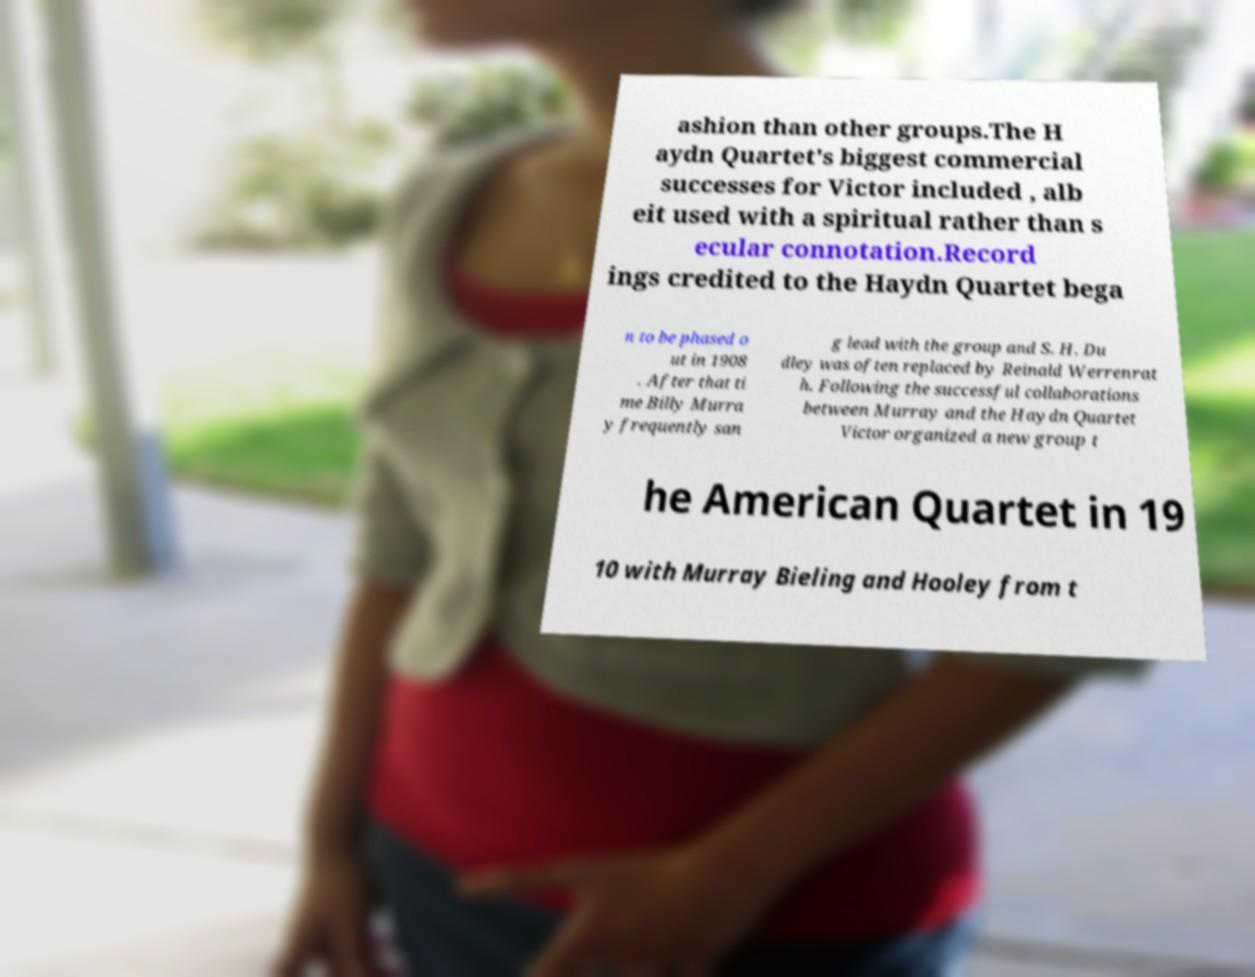Can you accurately transcribe the text from the provided image for me? ashion than other groups.The H aydn Quartet's biggest commercial successes for Victor included , alb eit used with a spiritual rather than s ecular connotation.Record ings credited to the Haydn Quartet bega n to be phased o ut in 1908 . After that ti me Billy Murra y frequently san g lead with the group and S. H. Du dley was often replaced by Reinald Werrenrat h. Following the successful collaborations between Murray and the Haydn Quartet Victor organized a new group t he American Quartet in 19 10 with Murray Bieling and Hooley from t 